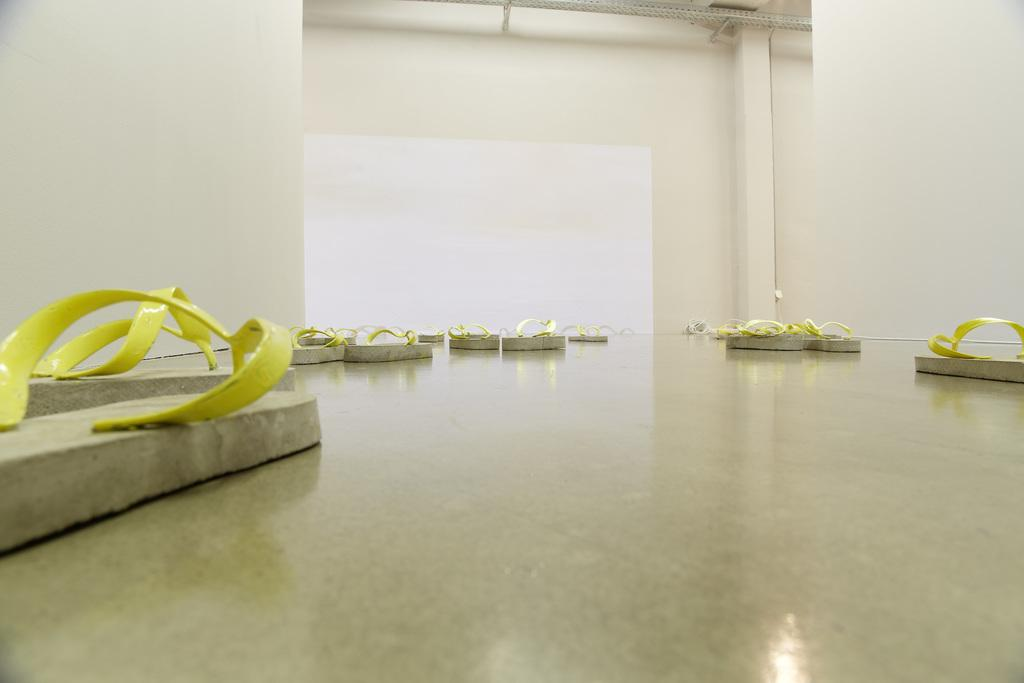What type of footwear is on the floor in the image? There are slippers on the floor. What can be seen in the background of the image? There is a wall and rods visible in the background of the image. Can you tell me how many pigs are visible in the image? There are no pigs present in the image. What type of body is shown in the image? There is no body present in the image; it only features slippers, a wall, and rods. 